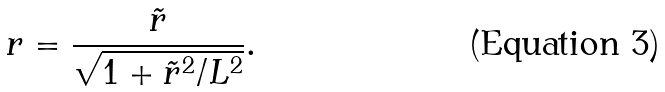Convert formula to latex. <formula><loc_0><loc_0><loc_500><loc_500>r = \frac { \tilde { r } } { \sqrt { 1 + \tilde { r } ^ { 2 } / L ^ { 2 } } } .</formula> 